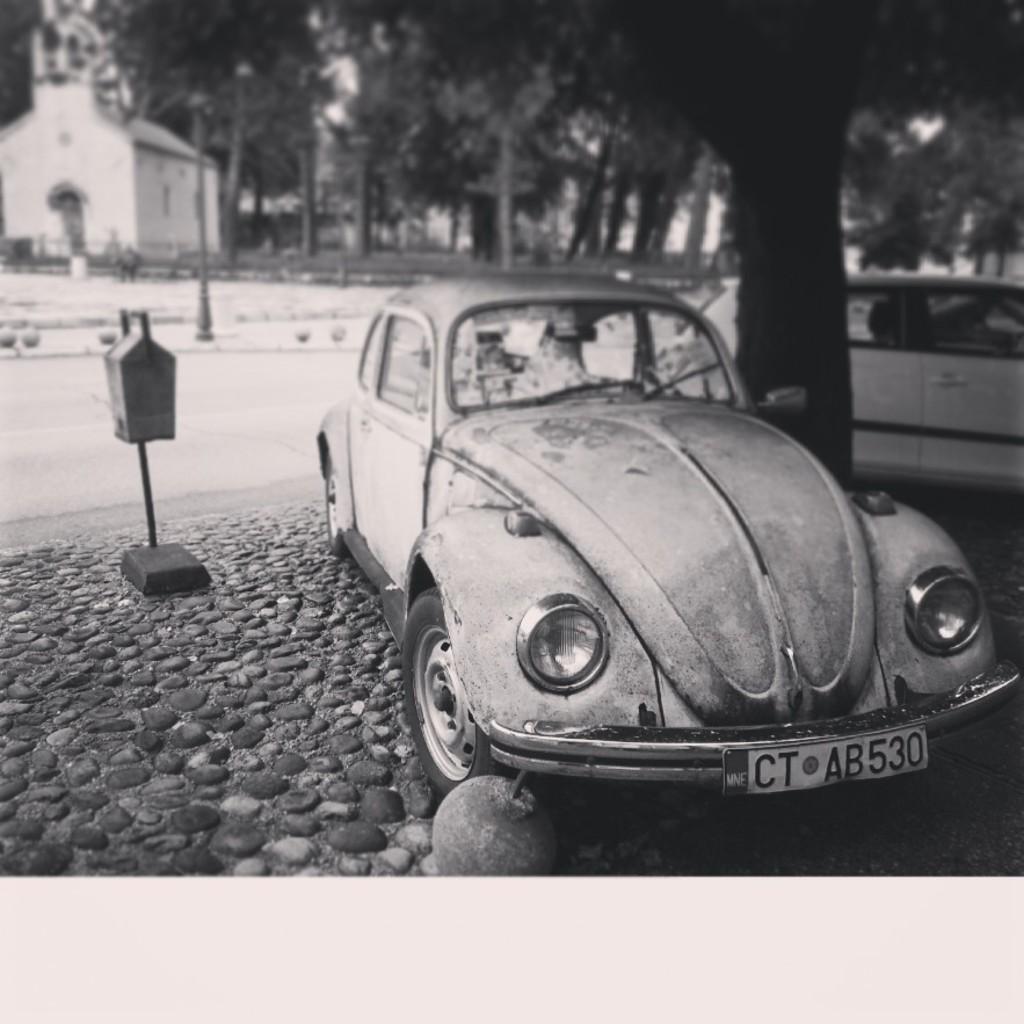Describe this image in one or two sentences. In this image we can see a house, there are trees, two cars, rocks, there is a box attached to a stand, there is a pole, and the picture is taken in black and white mode. 